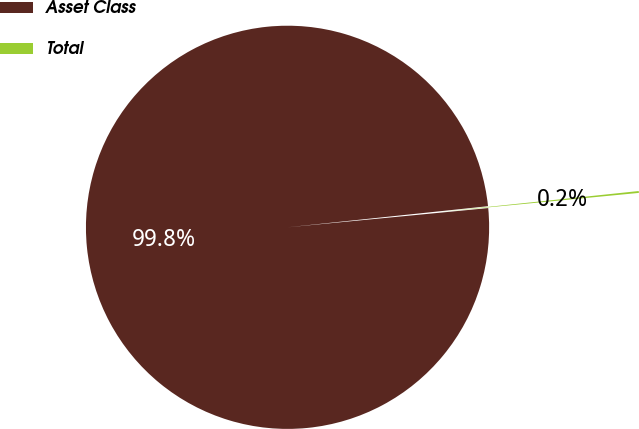Convert chart to OTSL. <chart><loc_0><loc_0><loc_500><loc_500><pie_chart><fcel>Asset Class<fcel>Total<nl><fcel>99.85%<fcel>0.15%<nl></chart> 